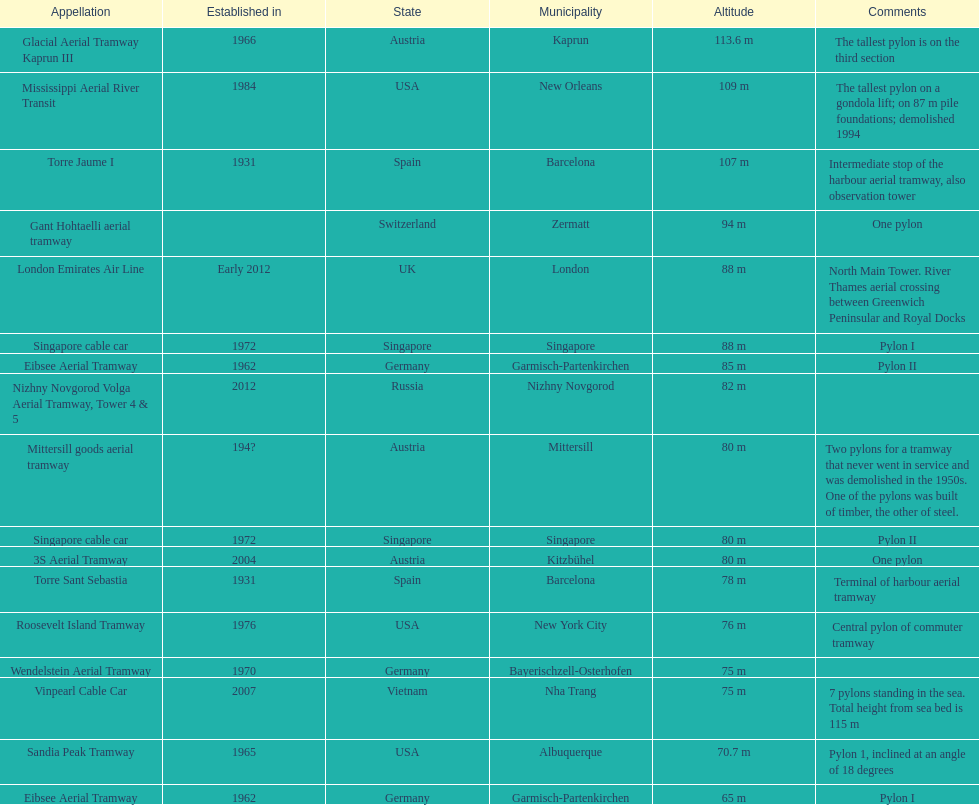What is the pylon with the least height listed here? Eibsee Aerial Tramway. 